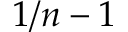<formula> <loc_0><loc_0><loc_500><loc_500>1 / n - 1</formula> 